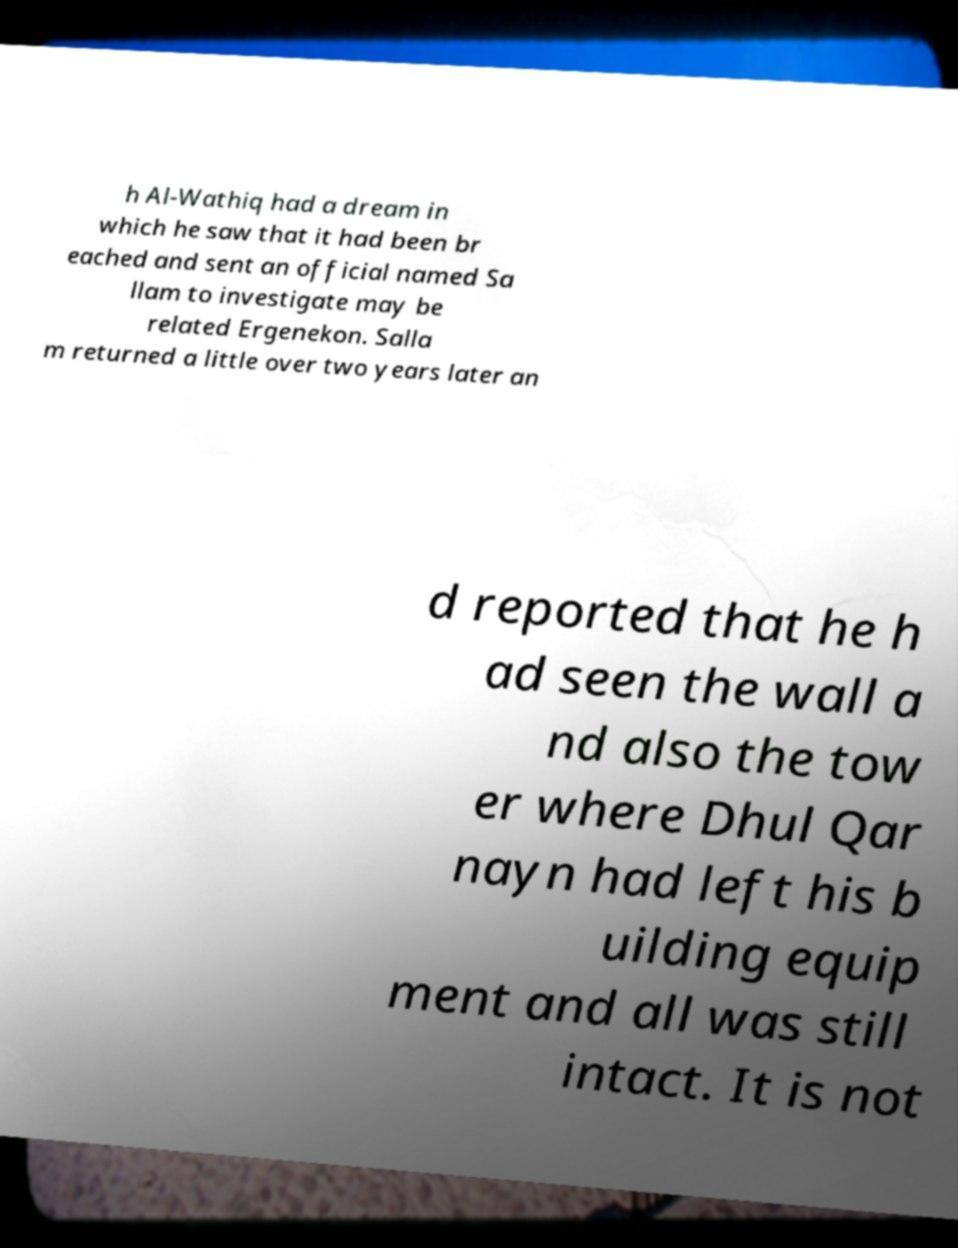Please read and relay the text visible in this image. What does it say? h Al-Wathiq had a dream in which he saw that it had been br eached and sent an official named Sa llam to investigate may be related Ergenekon. Salla m returned a little over two years later an d reported that he h ad seen the wall a nd also the tow er where Dhul Qar nayn had left his b uilding equip ment and all was still intact. It is not 